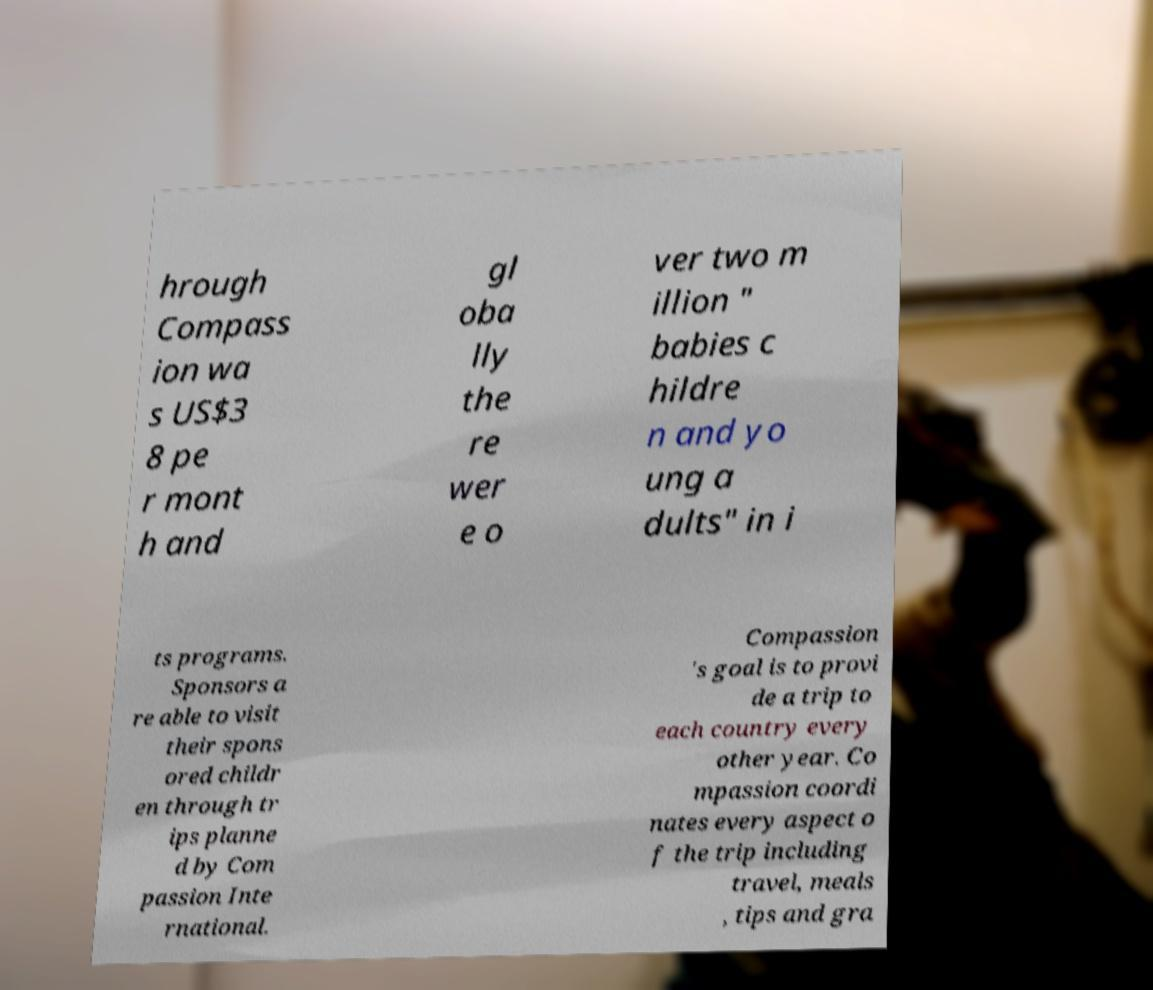For documentation purposes, I need the text within this image transcribed. Could you provide that? hrough Compass ion wa s US$3 8 pe r mont h and gl oba lly the re wer e o ver two m illion " babies c hildre n and yo ung a dults" in i ts programs. Sponsors a re able to visit their spons ored childr en through tr ips planne d by Com passion Inte rnational. Compassion 's goal is to provi de a trip to each country every other year. Co mpassion coordi nates every aspect o f the trip including travel, meals , tips and gra 